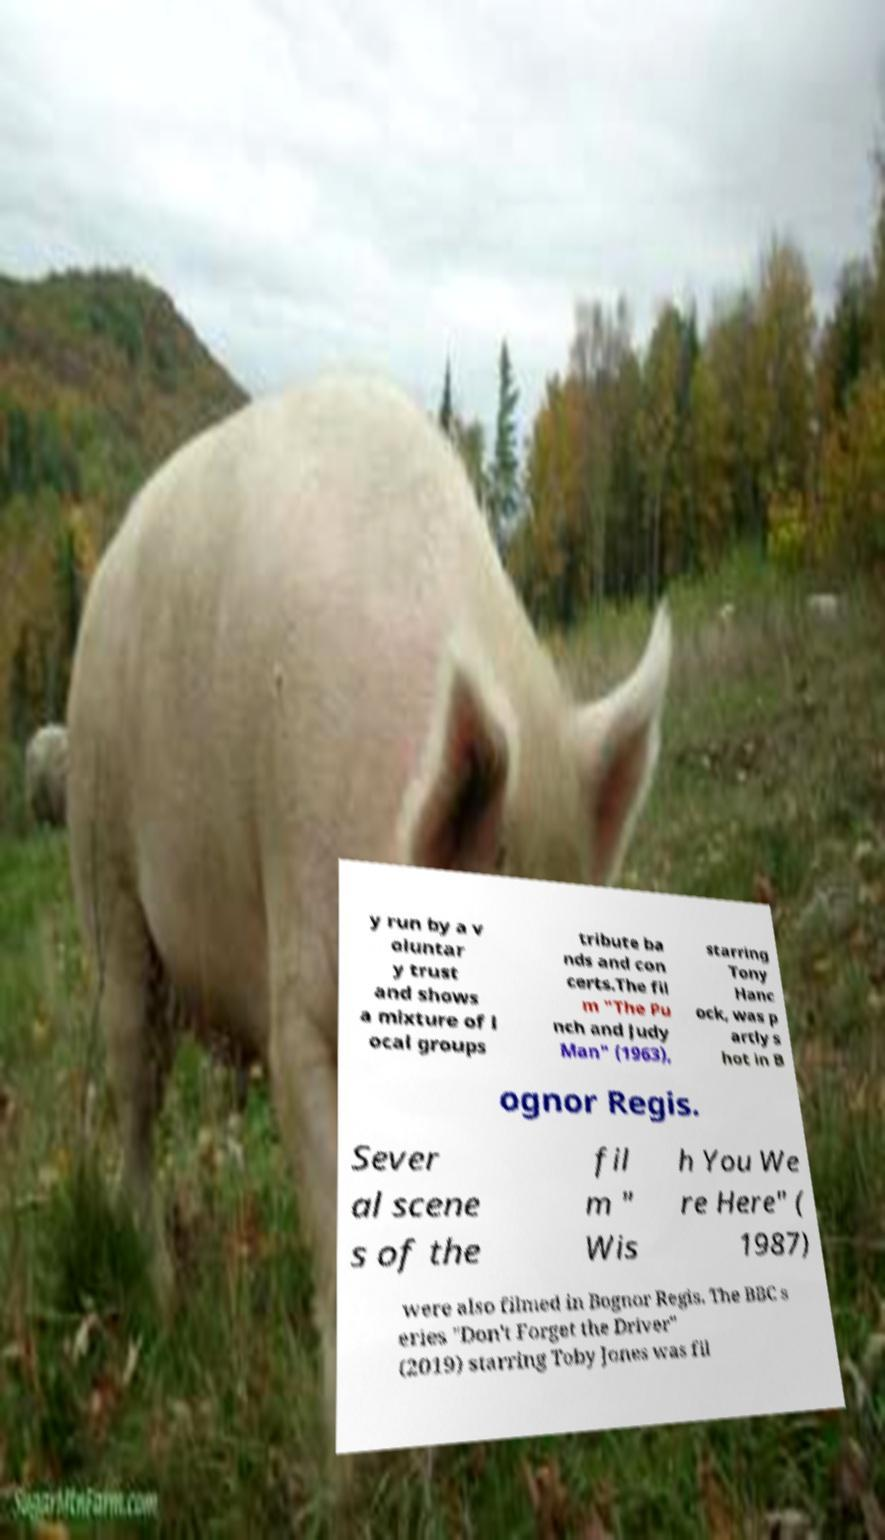Please read and relay the text visible in this image. What does it say? y run by a v oluntar y trust and shows a mixture of l ocal groups tribute ba nds and con certs.The fil m "The Pu nch and Judy Man" (1963), starring Tony Hanc ock, was p artly s hot in B ognor Regis. Sever al scene s of the fil m " Wis h You We re Here" ( 1987) were also filmed in Bognor Regis. The BBC s eries "Don't Forget the Driver" (2019) starring Toby Jones was fil 